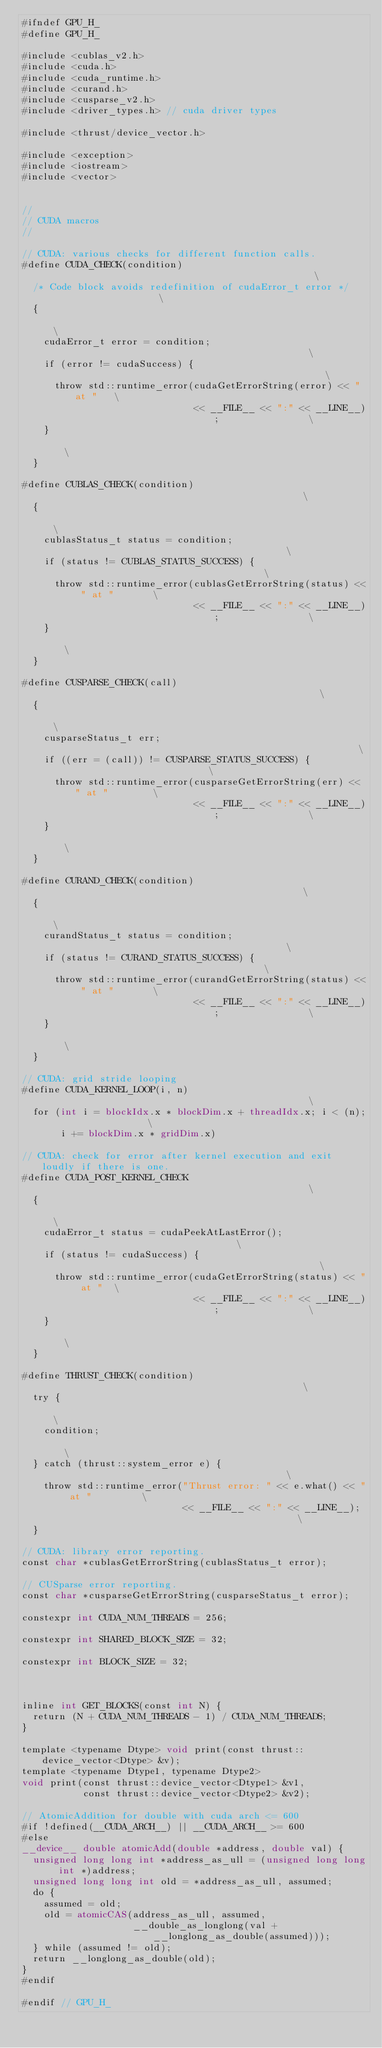<code> <loc_0><loc_0><loc_500><loc_500><_Cuda_>#ifndef GPU_H_
#define GPU_H_

#include <cublas_v2.h>
#include <cuda.h>
#include <cuda_runtime.h>
#include <curand.h>
#include <cusparse_v2.h>
#include <driver_types.h> // cuda driver types

#include <thrust/device_vector.h>

#include <exception>
#include <iostream>
#include <vector>


//
// CUDA macros
//

// CUDA: various checks for different function calls.
#define CUDA_CHECK(condition)                                                  \
  /* Code block avoids redefinition of cudaError_t error */                    \
  {                                                                            \
    cudaError_t error = condition;                                             \
    if (error != cudaSuccess) {                                                \
      throw std::runtime_error(cudaGetErrorString(error) << " at "   \
                               << __FILE__ << ":" << __LINE__);                \
    }                                                                          \
  }

#define CUBLAS_CHECK(condition)                                                \
  {                                                                            \
    cublasStatus_t status = condition;                                         \
    if (status != CUBLAS_STATUS_SUCCESS) {                                     \
      throw std::runtime_error(cublasGetErrorString(status) << " at "       \
                               << __FILE__ << ":" << __LINE__);                \
    }                                                                          \
  }

#define CUSPARSE_CHECK(call)                                                   \
  {                                                                            \
    cusparseStatus_t err;                                                      \
    if ((err = (call)) != CUSPARSE_STATUS_SUCCESS) {                           \
      throw std::runtime_error(cusparseGetErrorString(err) << " at "        \
                               << __FILE__ << ":" << __LINE__);                \
    }                                                                          \
  }

#define CURAND_CHECK(condition)                                                \
  {                                                                            \
    curandStatus_t status = condition;                                         \
    if (status != CURAND_STATUS_SUCCESS) {                                     \
      throw std::runtime_error(curandGetErrorString(status) << " at "       \
                               << __FILE__ << ":" << __LINE__);                \
    }                                                                          \
  }

// CUDA: grid stride looping
#define CUDA_KERNEL_LOOP(i, n)                                                 \
  for (int i = blockIdx.x * blockDim.x + threadIdx.x; i < (n);                 \
       i += blockDim.x * gridDim.x)

// CUDA: check for error after kernel execution and exit loudly if there is one.
#define CUDA_POST_KERNEL_CHECK                                                 \
  {                                                                            \
    cudaError_t status = cudaPeekAtLastError();                                \
    if (status != cudaSuccess) {                                               \
      throw std::runtime_error(cudaGetErrorString(status) << " at "  \
                               << __FILE__ << ":" << __LINE__);                \
    }                                                                          \
  }

#define THRUST_CHECK(condition)                                                \
  try {                                                                        \
    condition;                                                                 \
  } catch (thrust::system_error e) {                                           \
    throw std::runtime_error("Thrust error: " << e.what() << " at "         \
                             << __FILE__ << ":" << __LINE__);                  \
  }

// CUDA: library error reporting.
const char *cublasGetErrorString(cublasStatus_t error);

// CUSparse error reporting.
const char *cusparseGetErrorString(cusparseStatus_t error);

constexpr int CUDA_NUM_THREADS = 256;

constexpr int SHARED_BLOCK_SIZE = 32;

constexpr int BLOCK_SIZE = 32;



inline int GET_BLOCKS(const int N) {
  return (N + CUDA_NUM_THREADS - 1) / CUDA_NUM_THREADS;
}

template <typename Dtype> void print(const thrust::device_vector<Dtype> &v);
template <typename Dtype1, typename Dtype2>
void print(const thrust::device_vector<Dtype1> &v1,
           const thrust::device_vector<Dtype2> &v2);

// AtomicAddition for double with cuda arch <= 600
#if !defined(__CUDA_ARCH__) || __CUDA_ARCH__ >= 600
#else
__device__ double atomicAdd(double *address, double val) {
  unsigned long long int *address_as_ull = (unsigned long long int *)address;
  unsigned long long int old = *address_as_ull, assumed;
  do {
    assumed = old;
    old = atomicCAS(address_as_ull, assumed,
                    __double_as_longlong(val + __longlong_as_double(assumed)));
  } while (assumed != old);
  return __longlong_as_double(old);
}
#endif

#endif // GPU_H_

</code> 